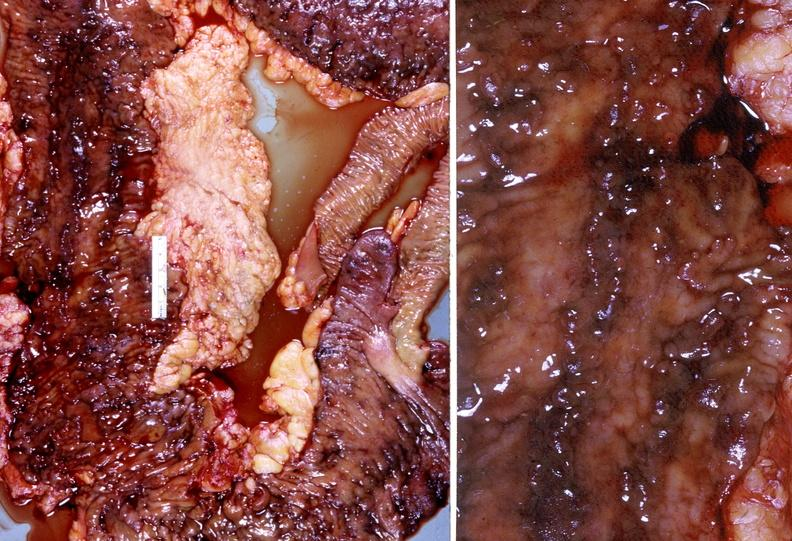s autoimmune thyroiditis present?
Answer the question using a single word or phrase. No 